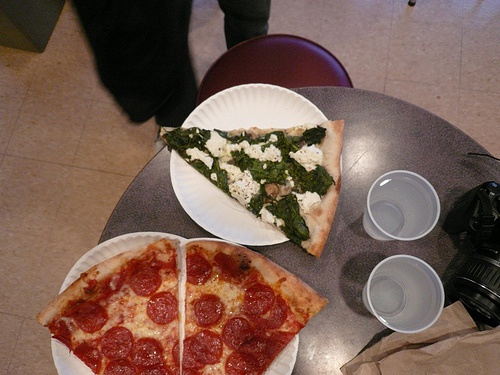Describe the objects in this image and their specific colors. I can see pizza in black, maroon, and brown tones, pizza in black, darkgreen, and tan tones, pizza in black, maroon, and brown tones, people in black and gray tones, and cup in black and gray tones in this image. 